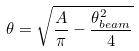Convert formula to latex. <formula><loc_0><loc_0><loc_500><loc_500>\theta = \sqrt { \frac { A } { \pi } - \frac { \theta ^ { 2 } _ { b e a m } } { 4 } }</formula> 